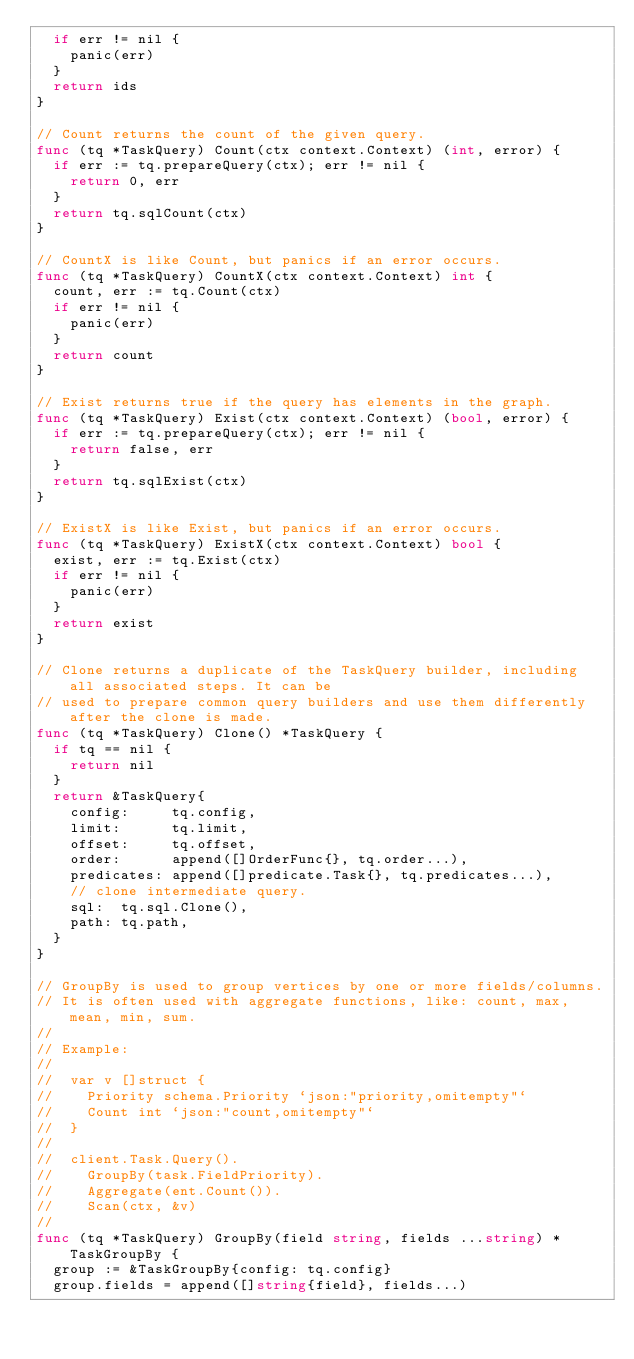<code> <loc_0><loc_0><loc_500><loc_500><_Go_>	if err != nil {
		panic(err)
	}
	return ids
}

// Count returns the count of the given query.
func (tq *TaskQuery) Count(ctx context.Context) (int, error) {
	if err := tq.prepareQuery(ctx); err != nil {
		return 0, err
	}
	return tq.sqlCount(ctx)
}

// CountX is like Count, but panics if an error occurs.
func (tq *TaskQuery) CountX(ctx context.Context) int {
	count, err := tq.Count(ctx)
	if err != nil {
		panic(err)
	}
	return count
}

// Exist returns true if the query has elements in the graph.
func (tq *TaskQuery) Exist(ctx context.Context) (bool, error) {
	if err := tq.prepareQuery(ctx); err != nil {
		return false, err
	}
	return tq.sqlExist(ctx)
}

// ExistX is like Exist, but panics if an error occurs.
func (tq *TaskQuery) ExistX(ctx context.Context) bool {
	exist, err := tq.Exist(ctx)
	if err != nil {
		panic(err)
	}
	return exist
}

// Clone returns a duplicate of the TaskQuery builder, including all associated steps. It can be
// used to prepare common query builders and use them differently after the clone is made.
func (tq *TaskQuery) Clone() *TaskQuery {
	if tq == nil {
		return nil
	}
	return &TaskQuery{
		config:     tq.config,
		limit:      tq.limit,
		offset:     tq.offset,
		order:      append([]OrderFunc{}, tq.order...),
		predicates: append([]predicate.Task{}, tq.predicates...),
		// clone intermediate query.
		sql:  tq.sql.Clone(),
		path: tq.path,
	}
}

// GroupBy is used to group vertices by one or more fields/columns.
// It is often used with aggregate functions, like: count, max, mean, min, sum.
//
// Example:
//
//	var v []struct {
//		Priority schema.Priority `json:"priority,omitempty"`
//		Count int `json:"count,omitempty"`
//	}
//
//	client.Task.Query().
//		GroupBy(task.FieldPriority).
//		Aggregate(ent.Count()).
//		Scan(ctx, &v)
//
func (tq *TaskQuery) GroupBy(field string, fields ...string) *TaskGroupBy {
	group := &TaskGroupBy{config: tq.config}
	group.fields = append([]string{field}, fields...)</code> 